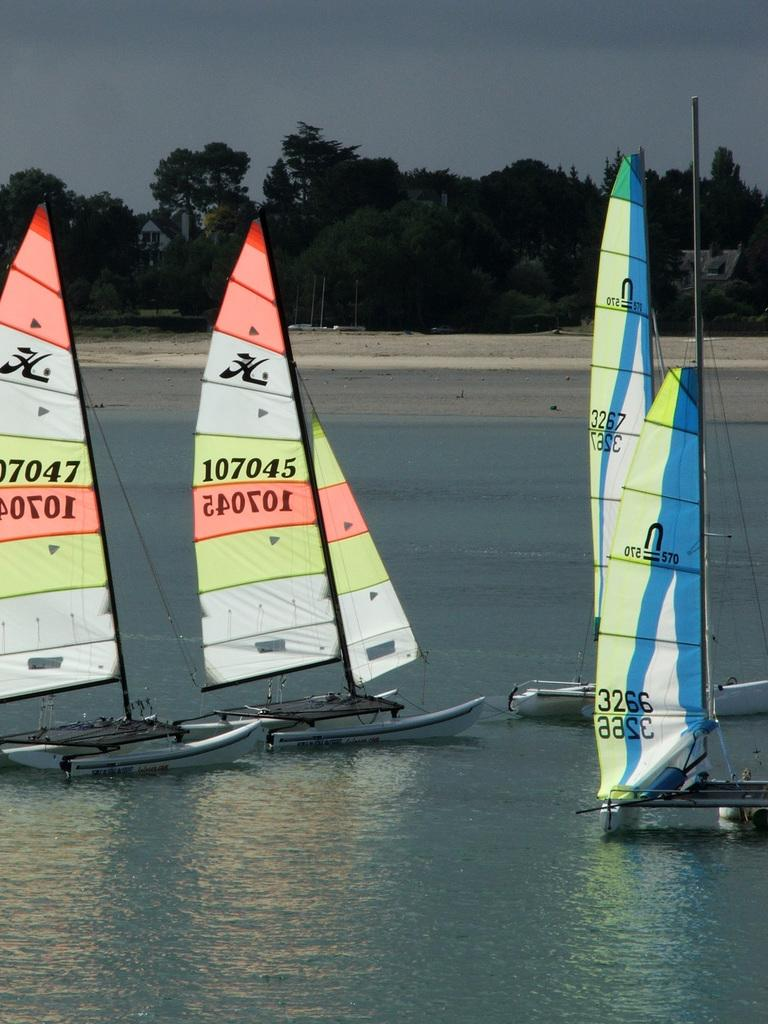<image>
Give a short and clear explanation of the subsequent image. An orange, white, and yellow sailboat with the number 107045 written on the sail. 